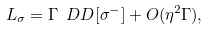<formula> <loc_0><loc_0><loc_500><loc_500>\L L _ { \sigma } = \Gamma \ D D [ \sigma ^ { - } ] + O ( \eta ^ { 2 } \Gamma ) ,</formula> 